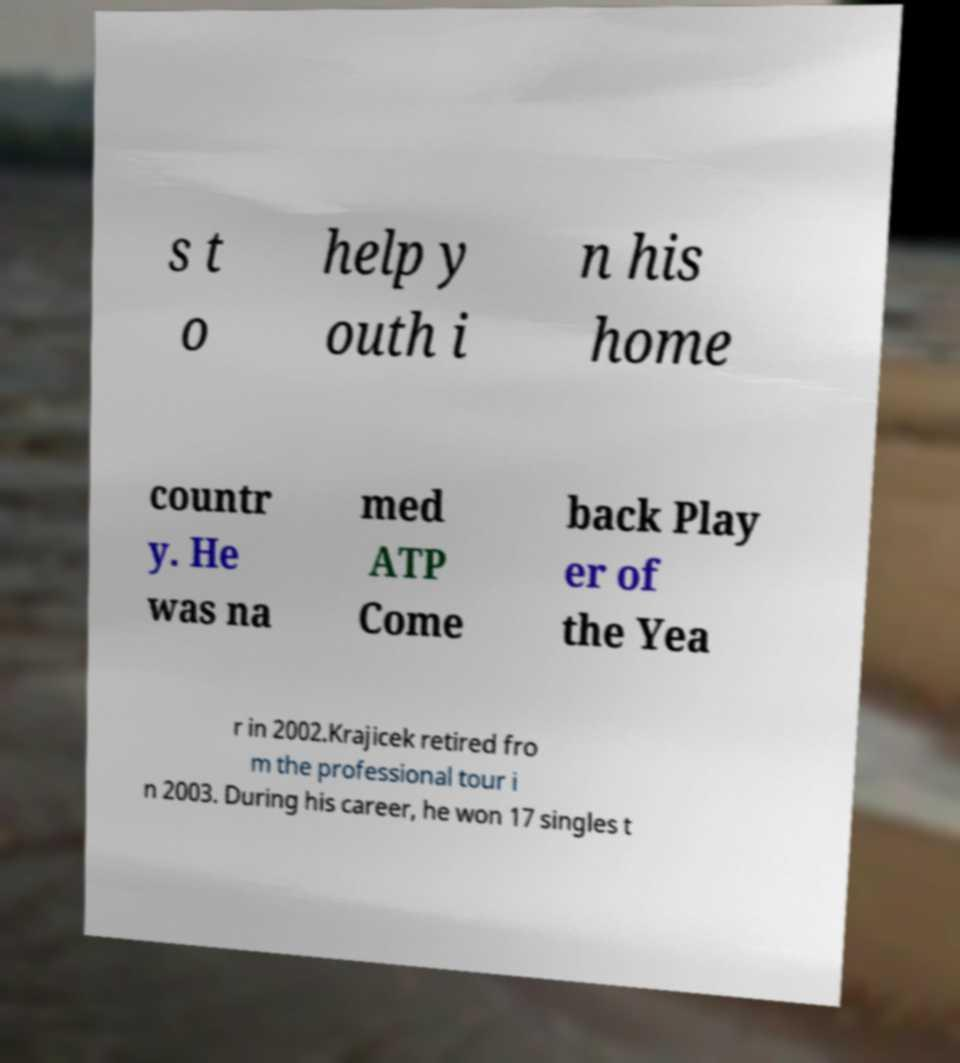What messages or text are displayed in this image? I need them in a readable, typed format. s t o help y outh i n his home countr y. He was na med ATP Come back Play er of the Yea r in 2002.Krajicek retired fro m the professional tour i n 2003. During his career, he won 17 singles t 